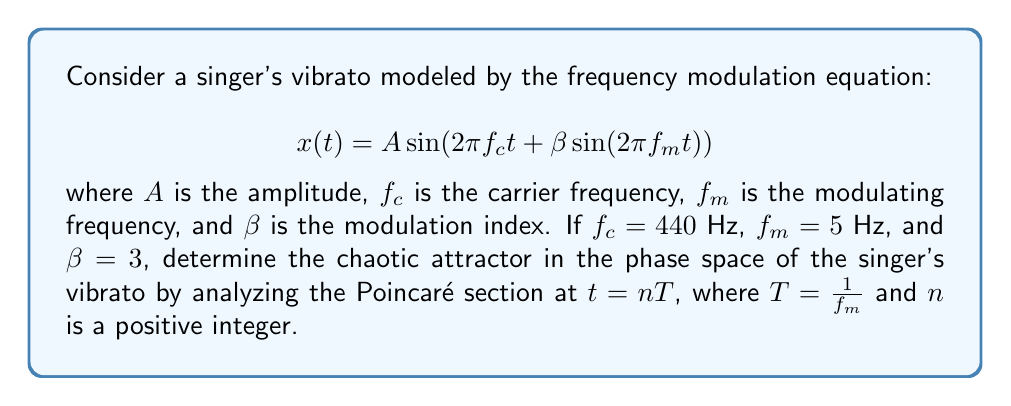Can you answer this question? To determine the chaotic attractor in the frequency modulation of a singer's vibrato, we need to follow these steps:

1) First, let's understand the given parameters:
   $f_c = 440$ Hz (carrier frequency, representing the main pitch)
   $f_m = 5$ Hz (modulating frequency, representing the vibrato rate)
   $\beta = 3$ (modulation index, representing the depth of vibrato)

2) The period of the modulating frequency is $T = \frac{1}{f_m} = \frac{1}{5} = 0.2$ seconds.

3) To construct the Poincaré section, we need to sample the system at intervals of $T$. This means we'll look at the state of the system every 0.2 seconds.

4) The phase space of this system is two-dimensional, represented by $(x, \dot{x})$, where $x$ is the displacement and $\dot{x}$ is the velocity.

5) To find $x$ and $\dot{x}$, we use the following equations:

   $$x(t) = A \sin(2\pi f_c t + \beta \sin(2\pi f_m t))$$
   $$\dot{x}(t) = A (2\pi f_c \cos(2\pi f_c t + \beta \sin(2\pi f_m t)) + 2\pi f_m \beta \cos(2\pi f_m t) \sin(2\pi f_c t + \beta \sin(2\pi f_m t)))$$

6) We would need to plot these points $(x(nT), \dot{x}(nT))$ for many values of $n$ to visualize the Poincaré section.

7) The resulting plot would show a strange attractor, specifically a fractal-like structure known as a "folded-towel" attractor. This is characteristic of quasi-periodic systems with two incommensurate frequencies (in this case, $f_c$ and $f_m$).

8) The folded-towel attractor indicates that the vibrato, while not truly chaotic, exhibits complex, non-repeating behavior. This complexity in the frequency modulation contributes to the richness and expressiveness of the singer's voice.
Answer: Folded-towel attractor 